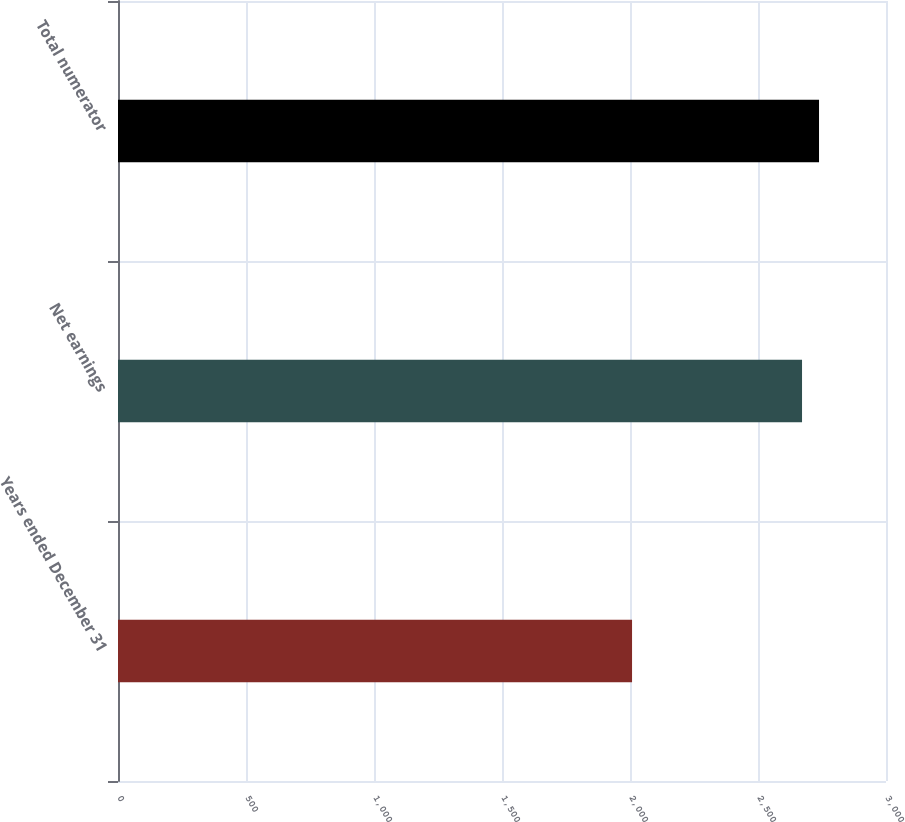Convert chart to OTSL. <chart><loc_0><loc_0><loc_500><loc_500><bar_chart><fcel>Years ended December 31<fcel>Net earnings<fcel>Total numerator<nl><fcel>2008<fcel>2672<fcel>2738.4<nl></chart> 